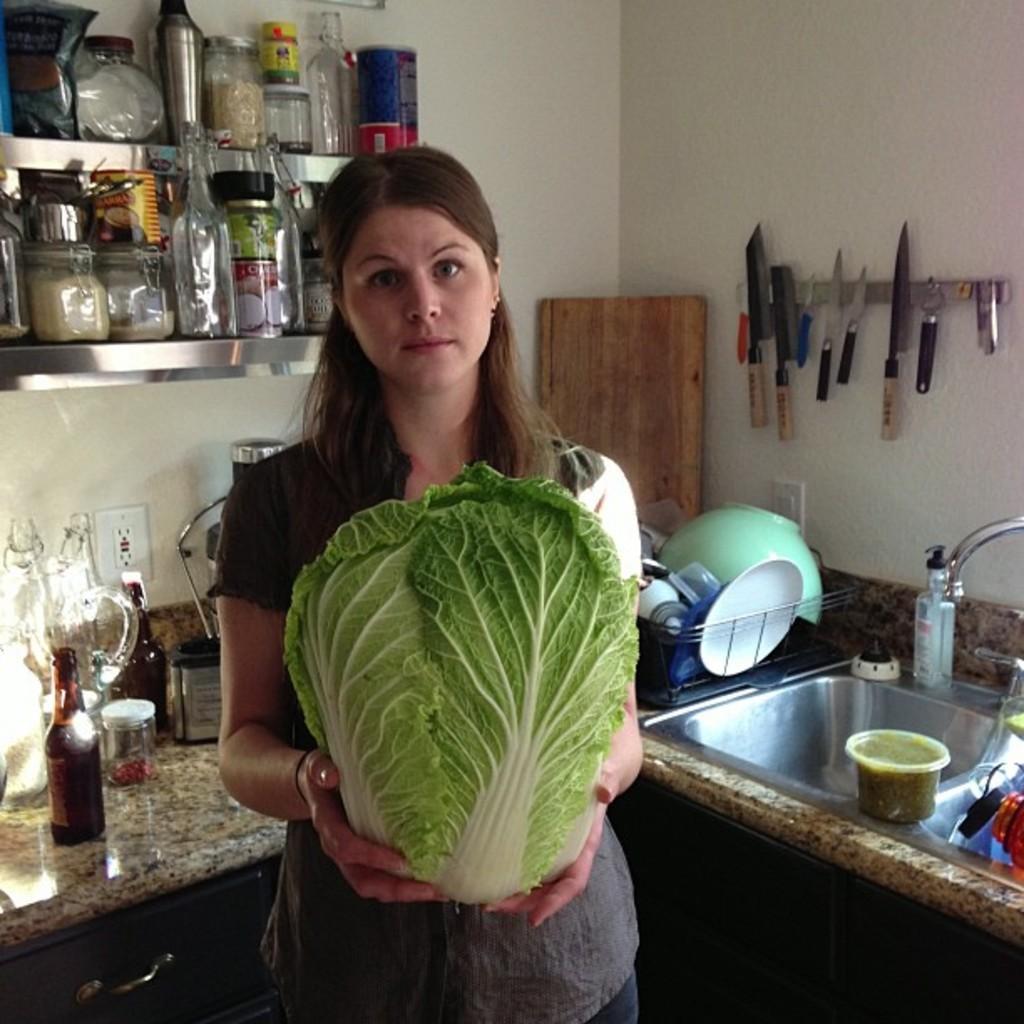In one or two sentences, can you explain what this image depicts? In this image I can see a person standing and holding cabbage which is in green color, at back I can see few bottles, bowls, plates on the counter top. At right I can see a sink, at back I can also see few knives hanged to a pole and wall is in cream color. 